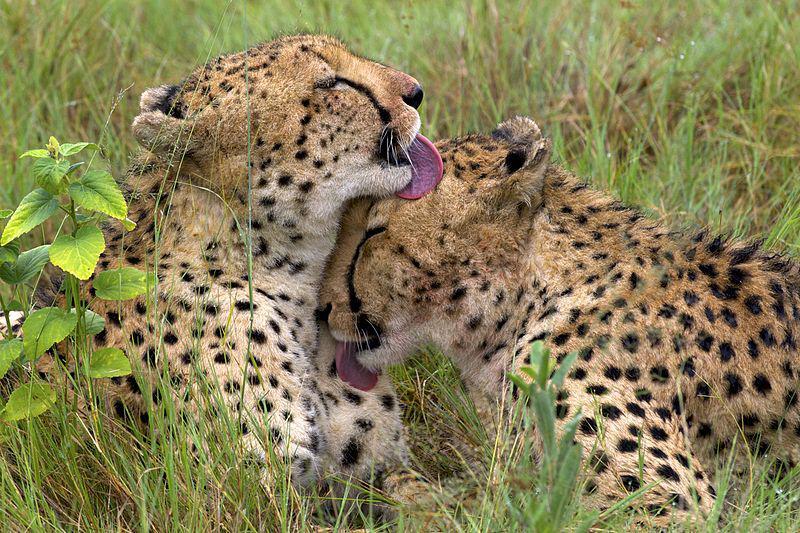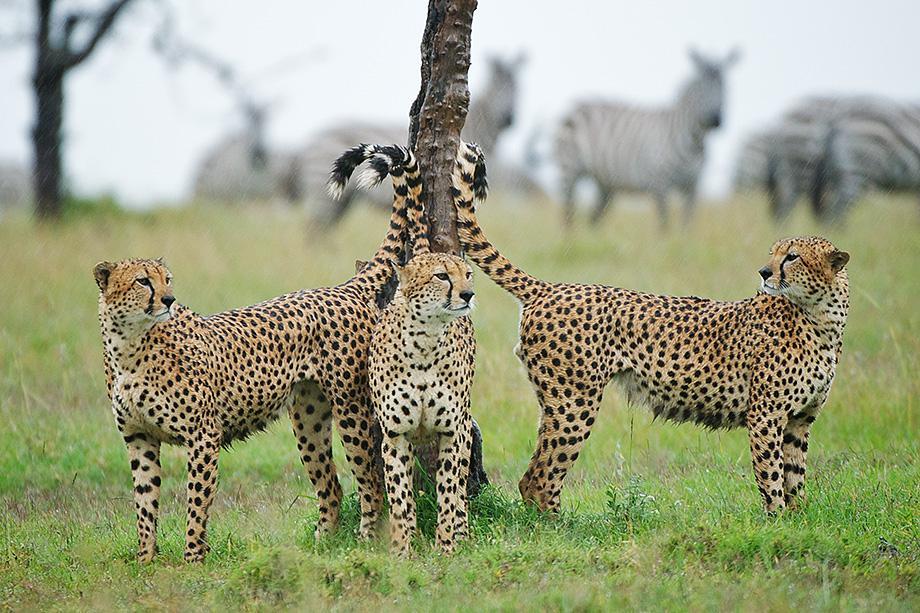The first image is the image on the left, the second image is the image on the right. Considering the images on both sides, is "More than one cat in the image on the left is lying down." valid? Answer yes or no. Yes. The first image is the image on the left, the second image is the image on the right. Assess this claim about the two images: "The left photo contains three or more cheetahs.". Correct or not? Answer yes or no. No. 